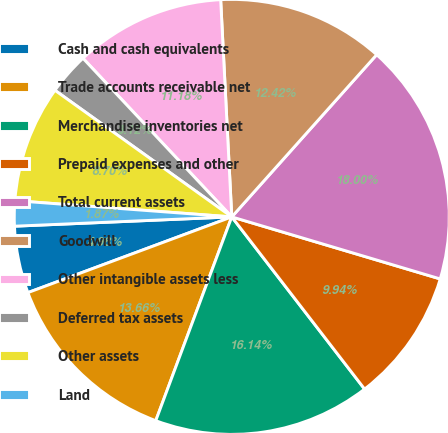Convert chart. <chart><loc_0><loc_0><loc_500><loc_500><pie_chart><fcel>Cash and cash equivalents<fcel>Trade accounts receivable net<fcel>Merchandise inventories net<fcel>Prepaid expenses and other<fcel>Total current assets<fcel>Goodwill<fcel>Other intangible assets less<fcel>Deferred tax assets<fcel>Other assets<fcel>Land<nl><fcel>4.98%<fcel>13.66%<fcel>16.14%<fcel>9.94%<fcel>18.0%<fcel>12.42%<fcel>11.18%<fcel>3.12%<fcel>8.7%<fcel>1.87%<nl></chart> 